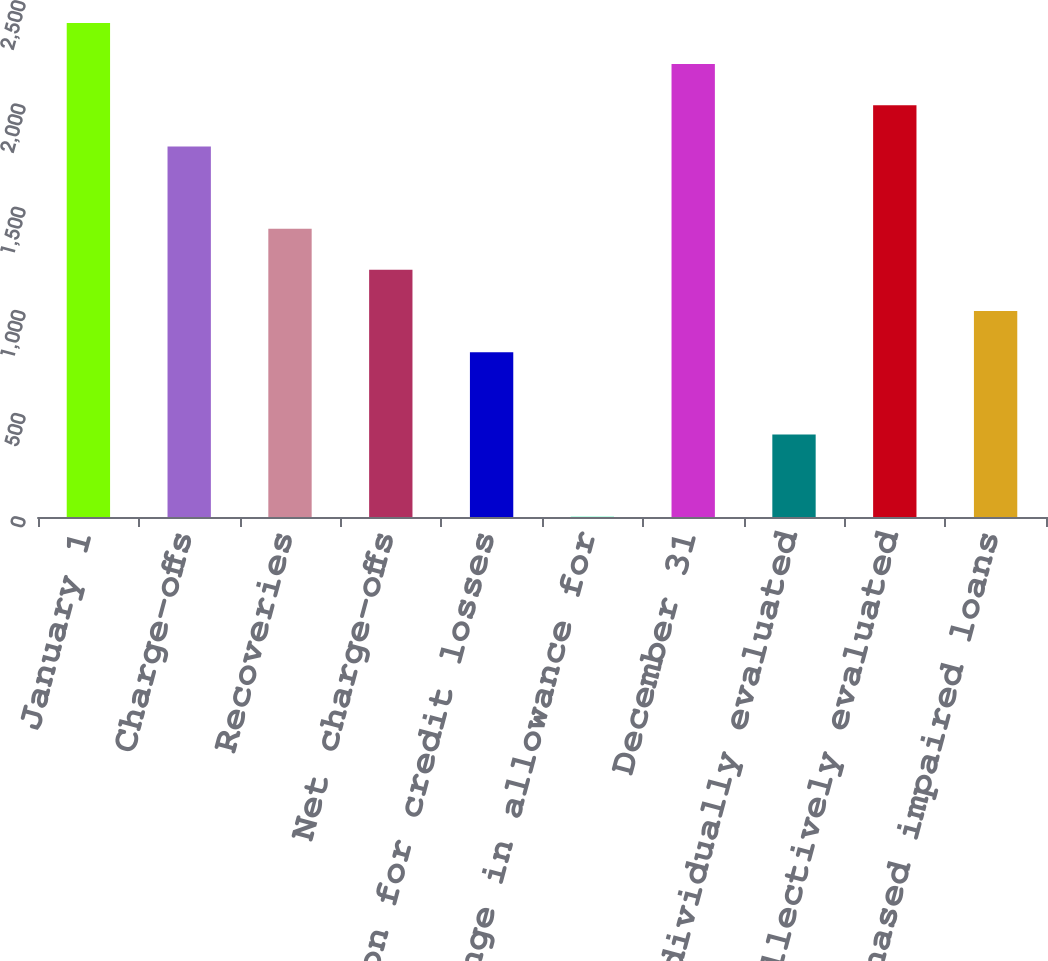<chart> <loc_0><loc_0><loc_500><loc_500><bar_chart><fcel>January 1<fcel>Charge-offs<fcel>Recoveries<fcel>Net charge-offs<fcel>Provision for credit losses<fcel>Net change in allowance for<fcel>December 31<fcel>TDRs individually evaluated<fcel>Loans collectively evaluated<fcel>Purchased impaired loans<nl><fcel>2393.8<fcel>1795.6<fcel>1396.8<fcel>1197.4<fcel>798.6<fcel>1<fcel>2194.4<fcel>399.8<fcel>1995<fcel>998<nl></chart> 